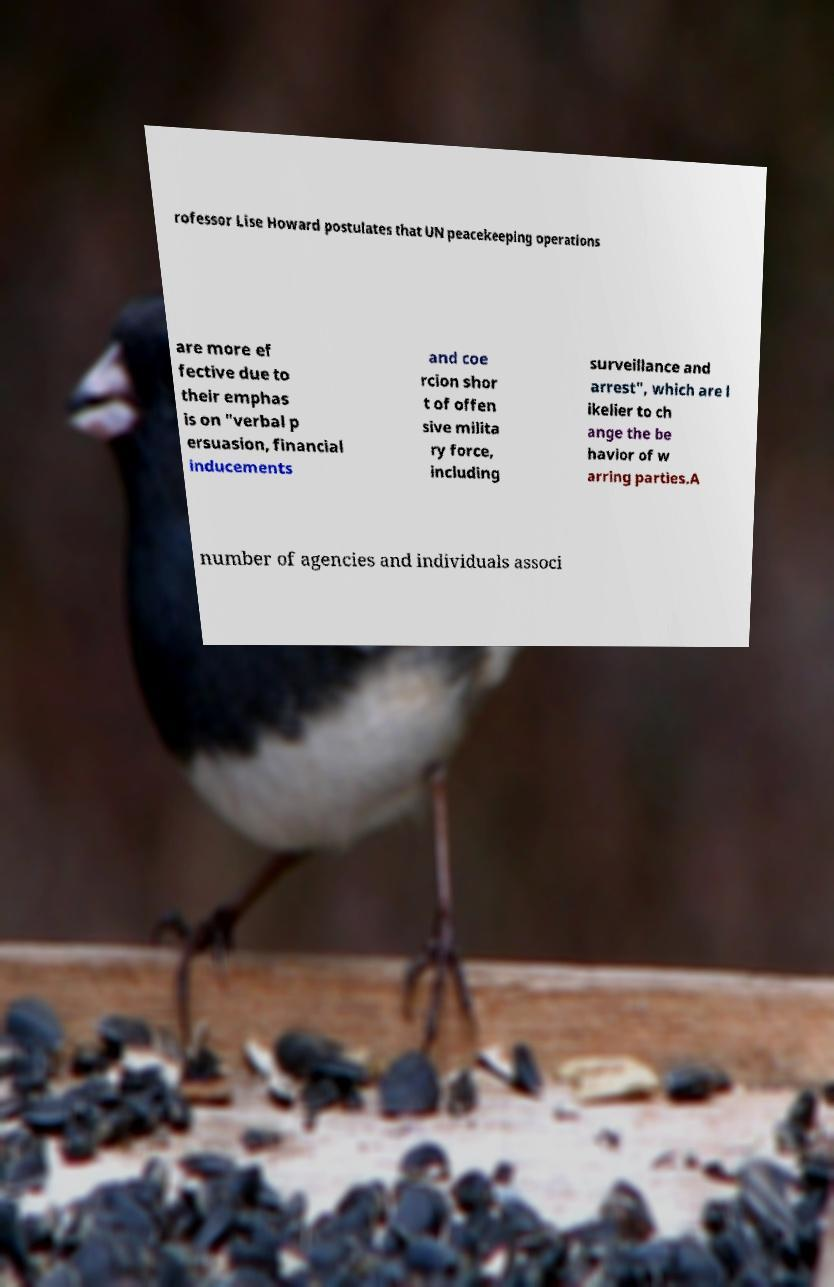What messages or text are displayed in this image? I need them in a readable, typed format. rofessor Lise Howard postulates that UN peacekeeping operations are more ef fective due to their emphas is on "verbal p ersuasion, financial inducements and coe rcion shor t of offen sive milita ry force, including surveillance and arrest", which are l ikelier to ch ange the be havior of w arring parties.A number of agencies and individuals associ 